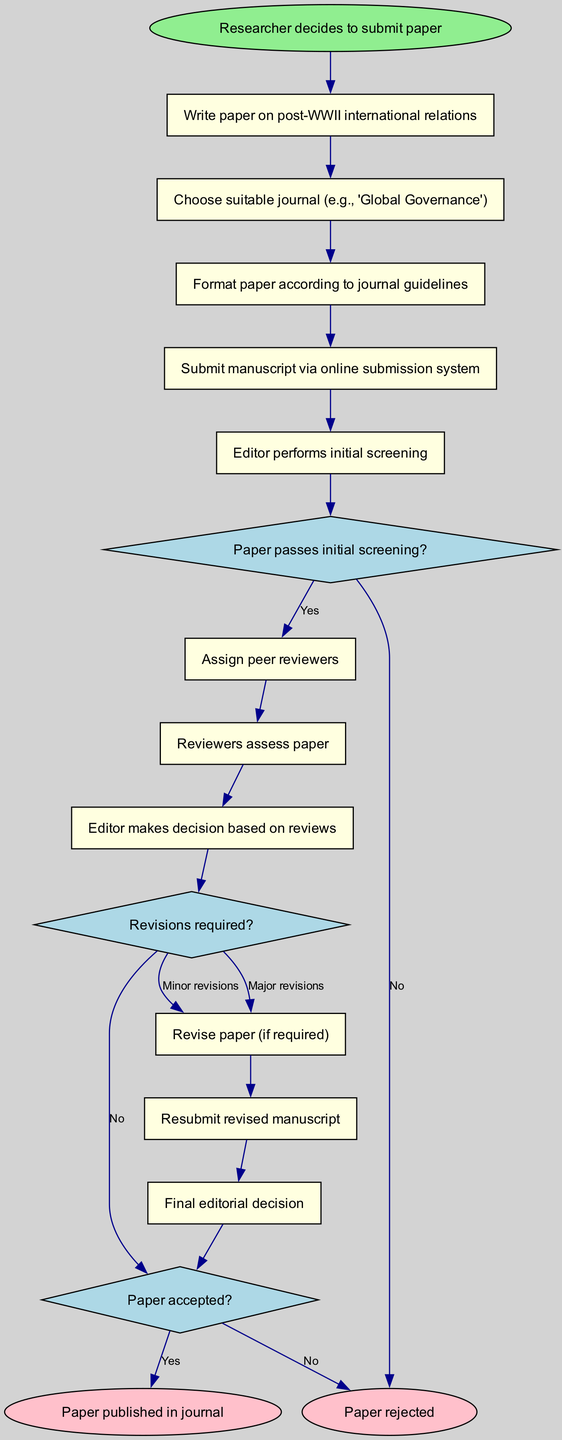What is the first activity in the workflow? The diagram lists "Write paper on post-WWII international relations" as the first activity directly following the start node.
Answer: Write paper on post-WWII international relations What decision is made after the initial screening? The decision made after the initial screening is whether "Paper passes initial screening?" which leads to either the assignment of peer reviewers or rejection.
Answer: Paper passes initial screening? How many end nodes are there in the diagram? The diagram contains two end nodes which represent the final outcomes of the workflow for the research paper.
Answer: 2 What happens if revisions are required? If revisions are required, the workflow indicates a transition to "Revise paper (if required)," indicating that the researcher must modify the paper before resubmitting it.
Answer: Revise paper (if required) How does the workflow conclude if the paper is accepted? If the paper is accepted, the workflow ends with "Paper published in journal," signifying the final successful outcome of the submission process.
Answer: Paper published in journal What is the label for the edge connecting "Editor makes decision based on reviews" to "Revise paper"? The edge is labeled "Major revisions," indicating that if significant changes are necessary, the researcher needs to revise the paper.
Answer: Major revisions How many activities are there in total before the final decision? Counting the activities from the beginning until the final decision, there are eight activities listed in the workflow excluding the initial decision-making process.
Answer: 8 What action follows after "Submit manuscript via online submission system"? The next action following "Submit manuscript via online submission system" is "Editor performs initial screening," establishing a sequence in the workflow.
Answer: Editor performs initial screening What decision path occurs if the paper is resubmitted again? If the paper is resubmitted, it continues back to "Final editorial decision" leading either to acceptance or rejection, creating a loop in the workflow.
Answer: Final editorial decision 